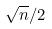<formula> <loc_0><loc_0><loc_500><loc_500>\sqrt { n } / 2</formula> 